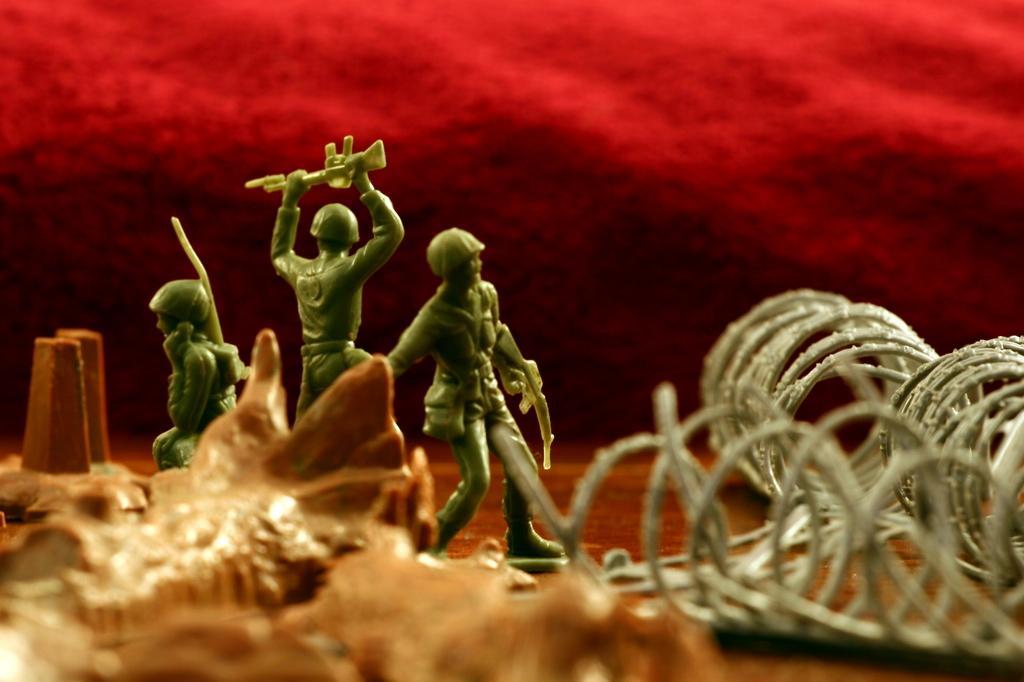How would you summarize this image in a sentence or two? In this picture, we can see a few toys, and we can see the ground, and some object on the bottom left side of the picture, we can see red color background. 